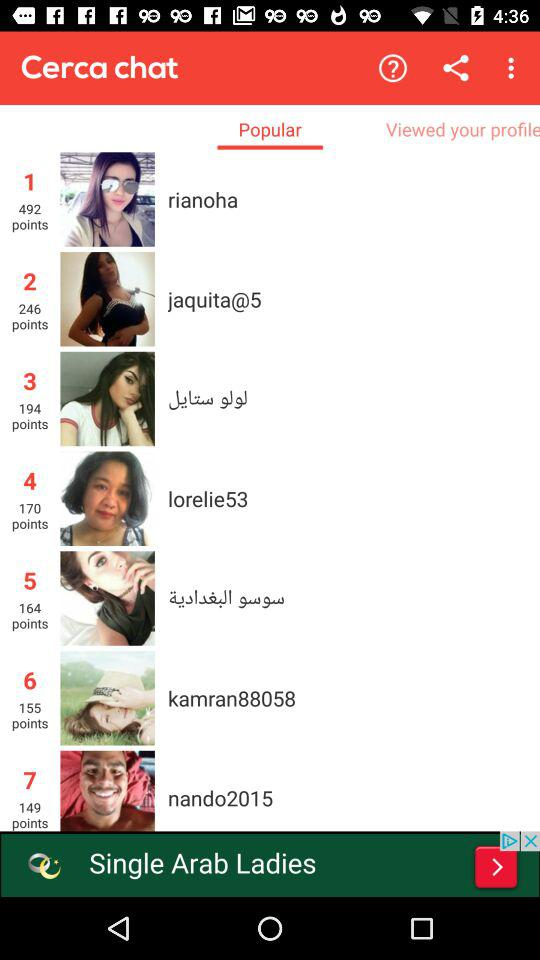Which tab is selected? The selected tab is "Popular". 